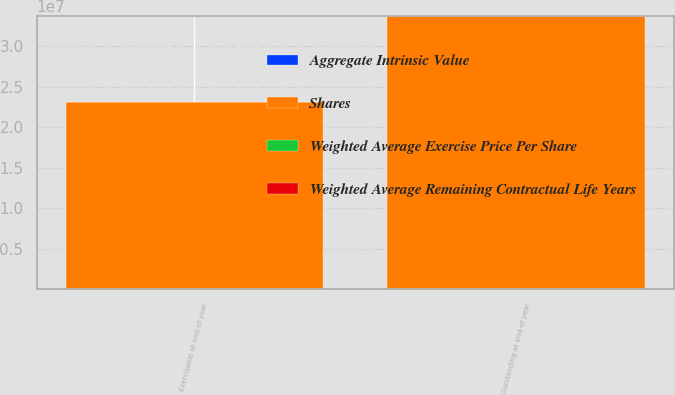Convert chart. <chart><loc_0><loc_0><loc_500><loc_500><stacked_bar_chart><ecel><fcel>Outstanding at end of year<fcel>Exercisable at end of year<nl><fcel>Shares<fcel>3.3664e+07<fcel>2.31213e+07<nl><fcel>Aggregate Intrinsic Value<fcel>71.81<fcel>71.55<nl><fcel>Weighted Average Exercise Price Per Share<fcel>6.28<fcel>5.18<nl><fcel>Weighted Average Remaining Contractual Life Years<fcel>232<fcel>200<nl></chart> 